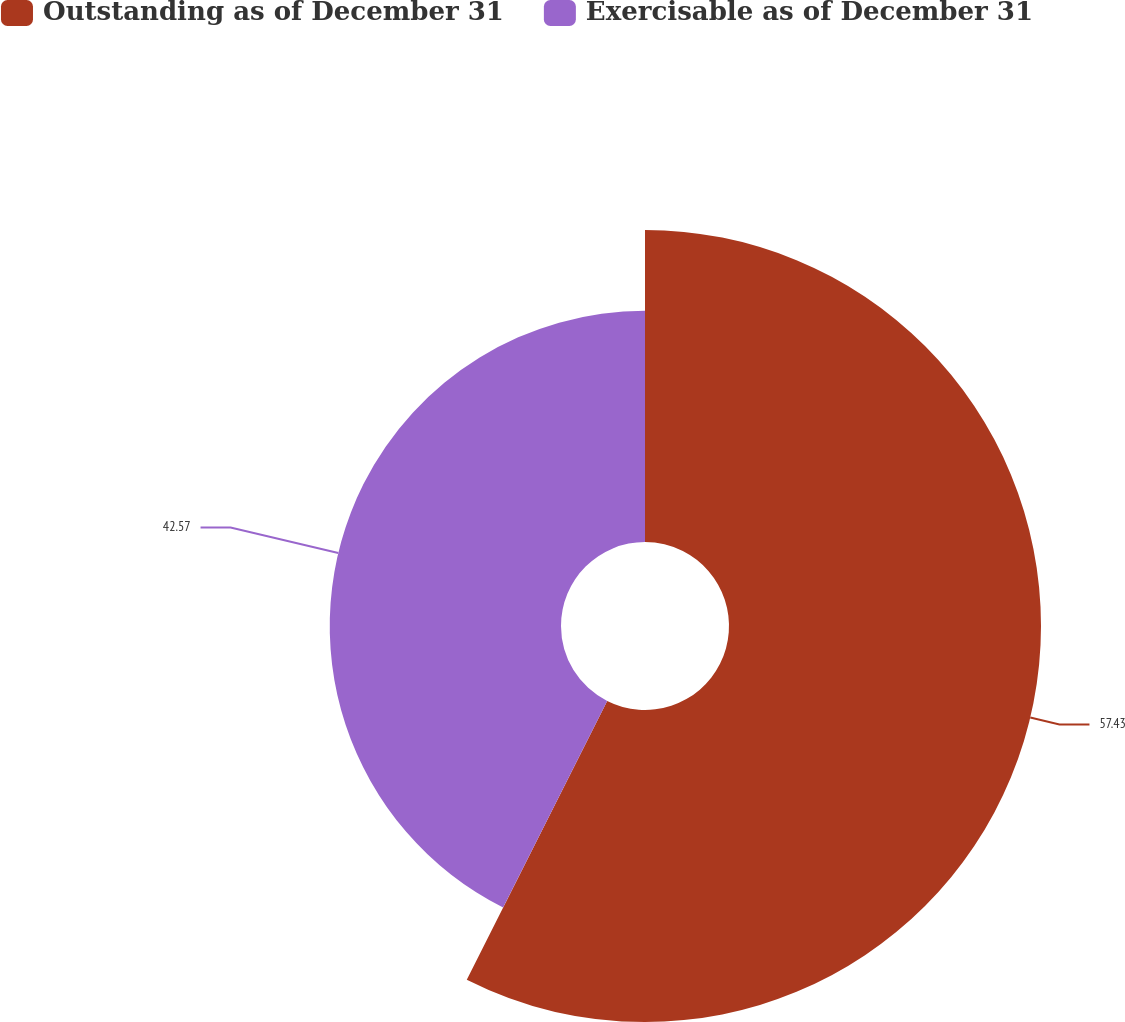Convert chart. <chart><loc_0><loc_0><loc_500><loc_500><pie_chart><fcel>Outstanding as of December 31<fcel>Exercisable as of December 31<nl><fcel>57.43%<fcel>42.57%<nl></chart> 